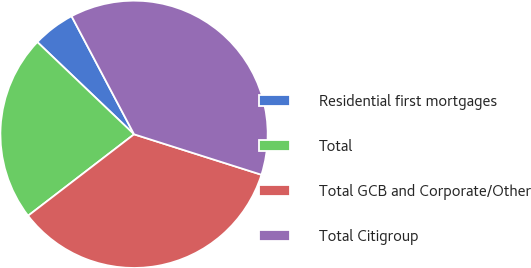Convert chart. <chart><loc_0><loc_0><loc_500><loc_500><pie_chart><fcel>Residential first mortgages<fcel>Total<fcel>Total GCB and Corporate/Other<fcel>Total Citigroup<nl><fcel>5.13%<fcel>22.55%<fcel>34.68%<fcel>37.64%<nl></chart> 